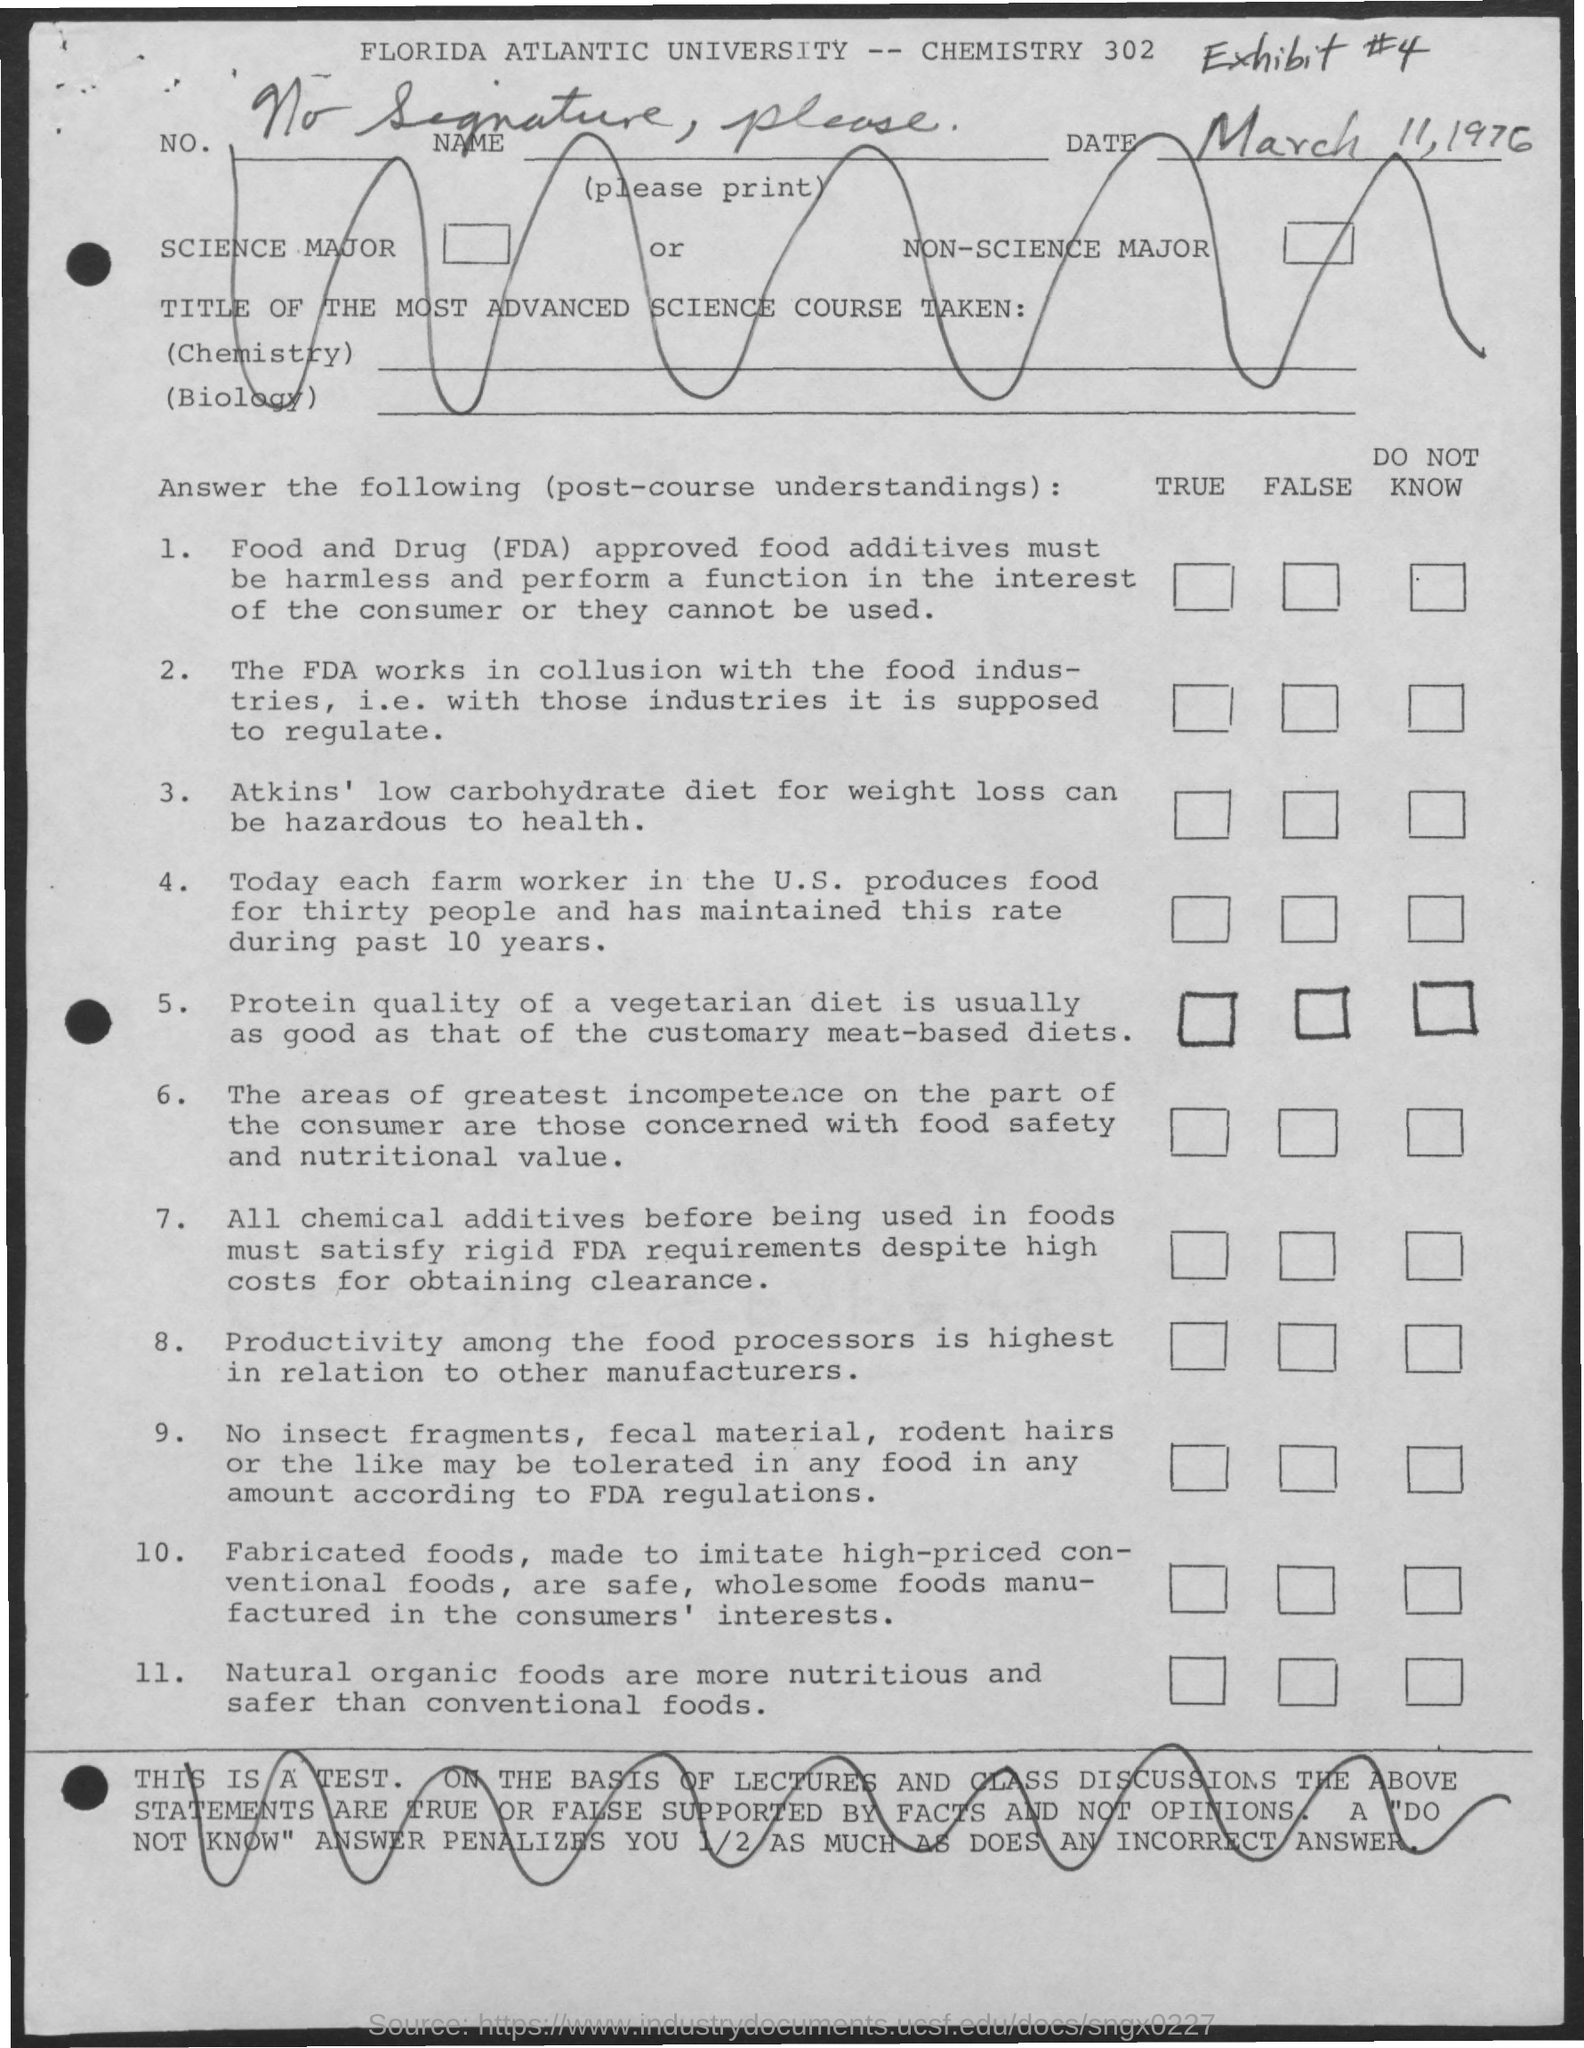What is the date mentioned at the top right?
Provide a succinct answer. March 11, 1976. What is the name of the University mentioned on the top?
Make the answer very short. Florida Atlantic University. 